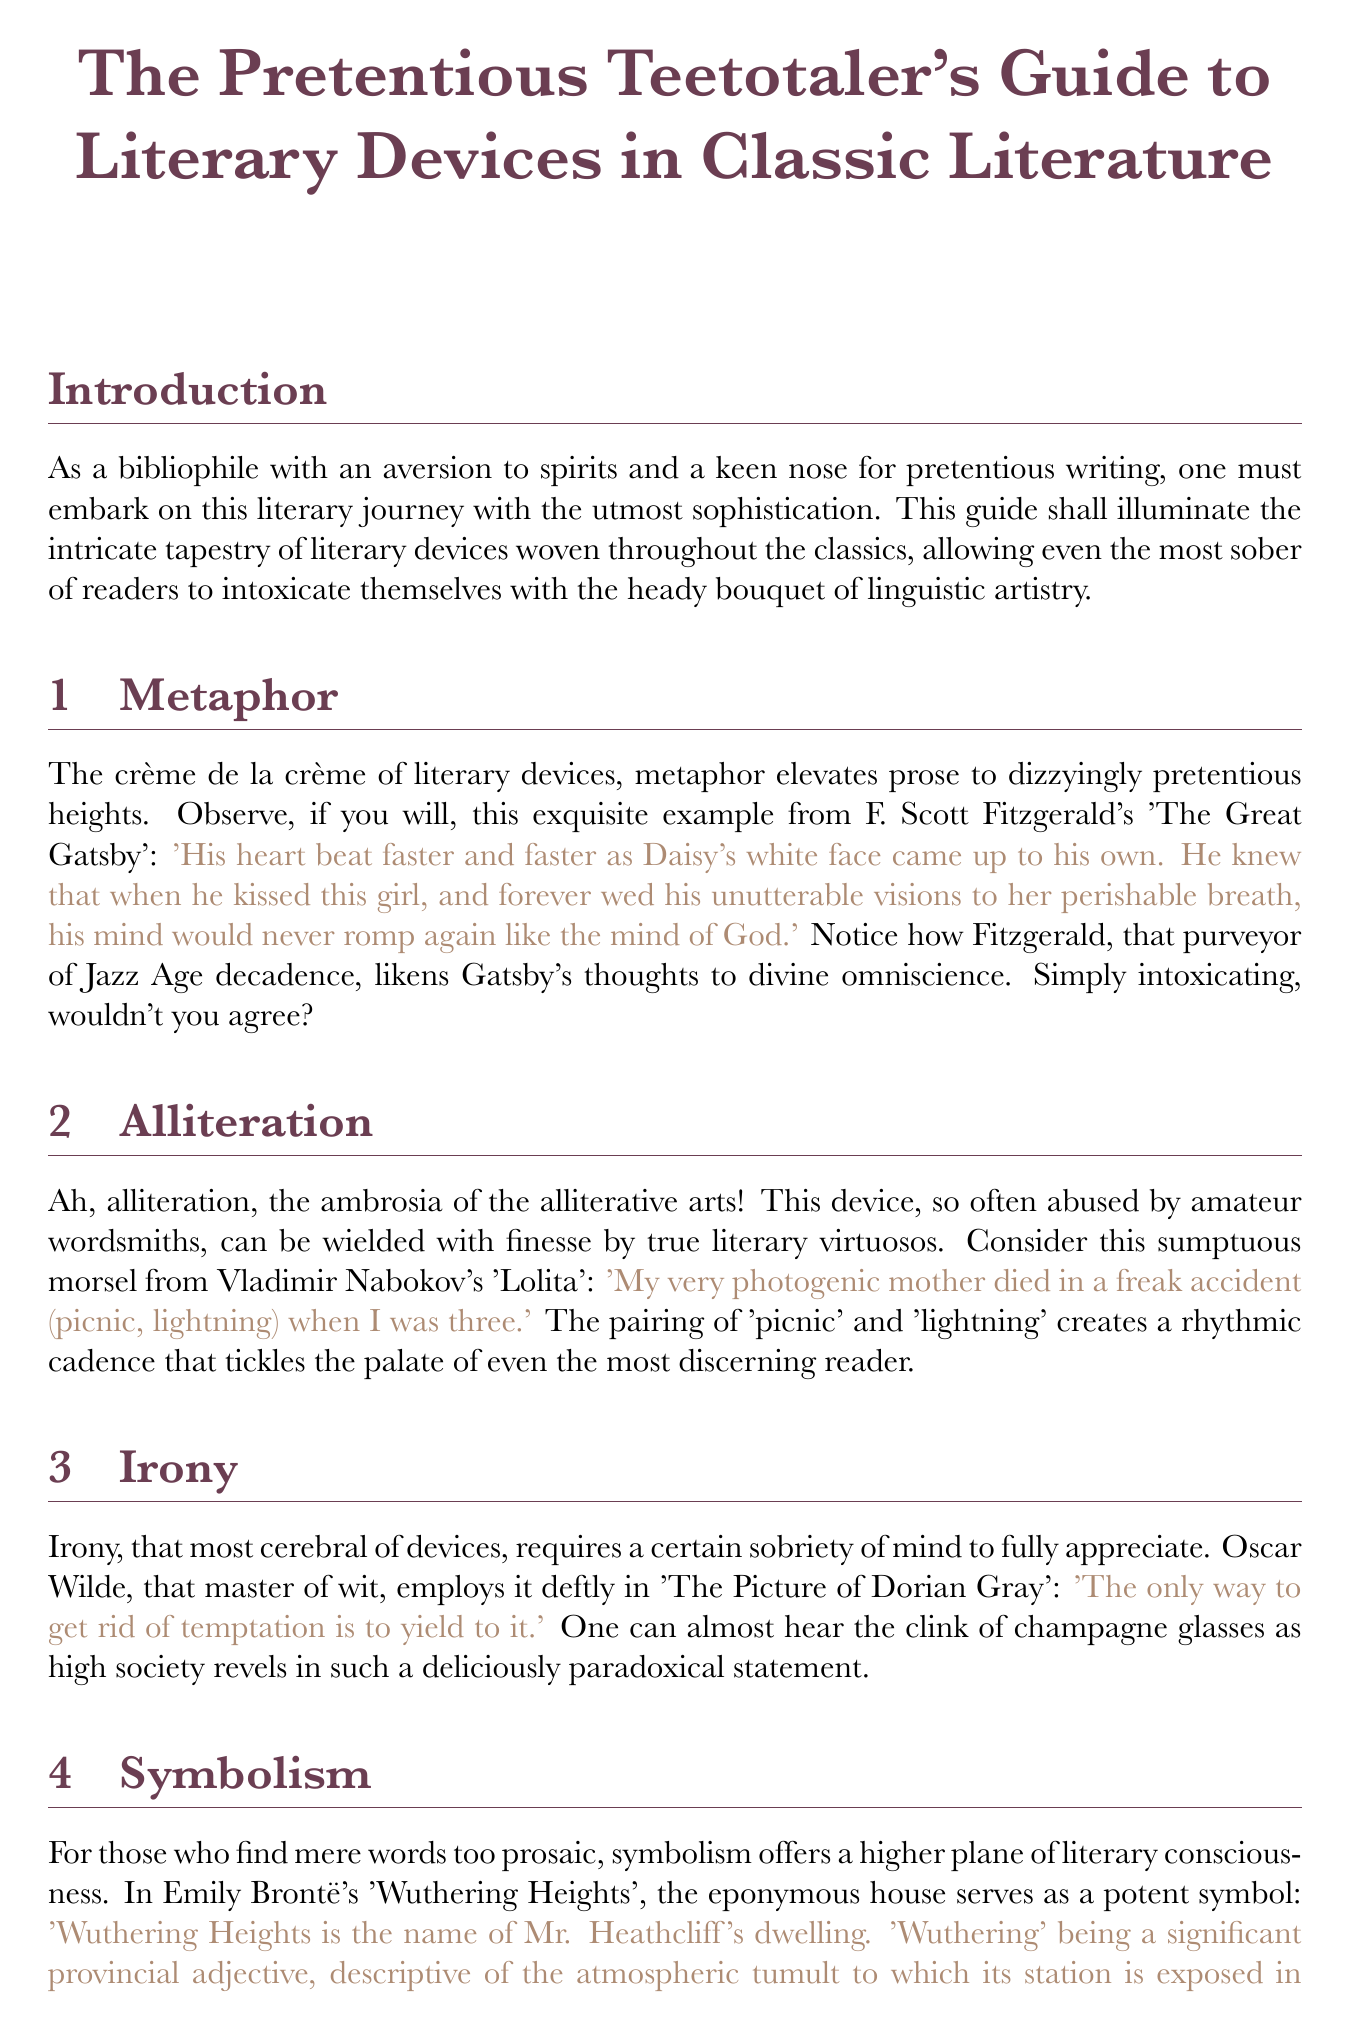what is the title of the manual? The title is explicitly stated at the beginning of the document.
Answer: The Pretentious Teetotaler's Guide to Literary Devices in Classic Literature who is the author of the metaphor example? The example of metaphor provided is from a well-known author in classic literature.
Answer: F. Scott Fitzgerald which device does Nabokov's quote illustrate? The quote from Nabokov is designed to showcase a specific literary device used in his work.
Answer: Alliteration what is the quote by Mark Twain about? The quote captures the essence of what defines a classic according to the author.
Answer: A classic is something that everybody wants to have read and nobody wants to read how many sections are in the document? The sections are listed sequentially within the document and the total can be counted.
Answer: Five who employs irony in their work? The document mentions a famous author known for their mastery of irony.
Answer: Oscar Wilde what color is used for the metaphor example? The color is specified in the document for the example of metaphor for visual emphasis.
Answer: Green what concept is discussed in the conclusion? The conclusion reflects on the appreciation of literary artistry without the influence of alcohol.
Answer: Appreciation which literary device is described as the "ambrosia of the alliterative arts"? The description in the document refers to a specific device highlighted in the section.
Answer: Alliteration 